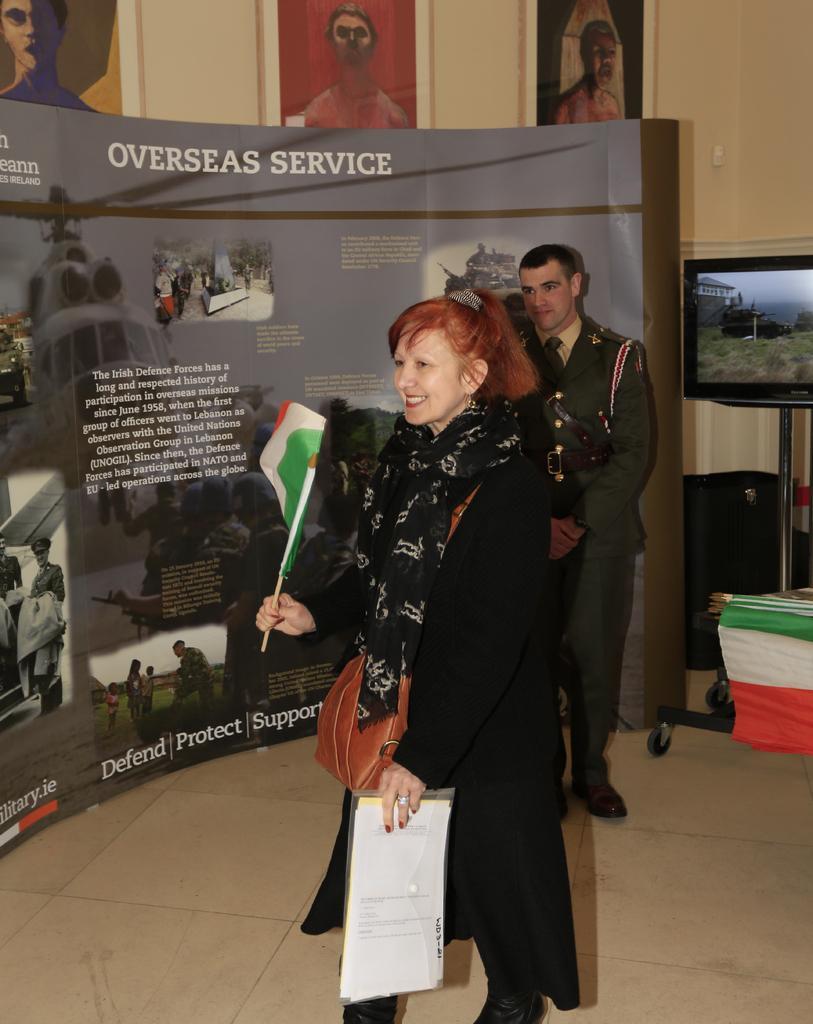Can you describe this image briefly? There is one woman standing and holding papers at the bottom of this image. We can see a wall poster as we can see on the left side of this image. There is a wall in the background, we can see photo frames attached to it. There is a television on the right side of this image. 